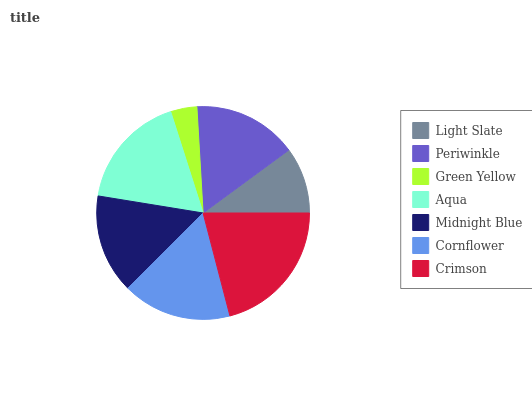Is Green Yellow the minimum?
Answer yes or no. Yes. Is Crimson the maximum?
Answer yes or no. Yes. Is Periwinkle the minimum?
Answer yes or no. No. Is Periwinkle the maximum?
Answer yes or no. No. Is Periwinkle greater than Light Slate?
Answer yes or no. Yes. Is Light Slate less than Periwinkle?
Answer yes or no. Yes. Is Light Slate greater than Periwinkle?
Answer yes or no. No. Is Periwinkle less than Light Slate?
Answer yes or no. No. Is Periwinkle the high median?
Answer yes or no. Yes. Is Periwinkle the low median?
Answer yes or no. Yes. Is Aqua the high median?
Answer yes or no. No. Is Cornflower the low median?
Answer yes or no. No. 